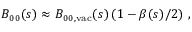<formula> <loc_0><loc_0><loc_500><loc_500>B _ { 0 0 } ( s ) \approx B _ { 0 0 , v a c } ( s ) \left ( 1 - \beta ( s ) / 2 \right ) \, ,</formula> 